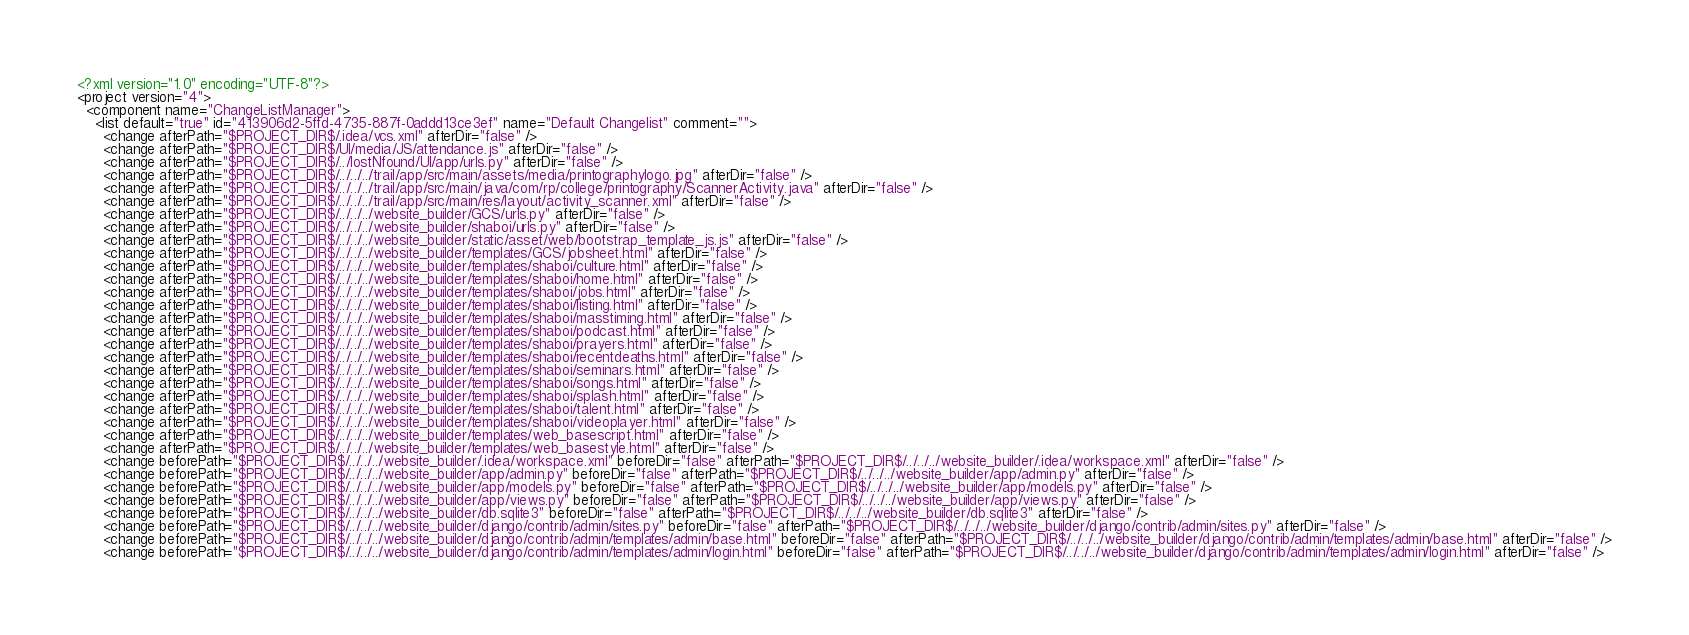<code> <loc_0><loc_0><loc_500><loc_500><_XML_><?xml version="1.0" encoding="UTF-8"?>
<project version="4">
  <component name="ChangeListManager">
    <list default="true" id="413906d2-5ffd-4735-887f-0addd13ce3ef" name="Default Changelist" comment="">
      <change afterPath="$PROJECT_DIR$/.idea/vcs.xml" afterDir="false" />
      <change afterPath="$PROJECT_DIR$/UI/media/JS/attendance.js" afterDir="false" />
      <change afterPath="$PROJECT_DIR$/../lostNfound/UI/app/urls.py" afterDir="false" />
      <change afterPath="$PROJECT_DIR$/../../../trail/app/src/main/assets/media/printographylogo.jpg" afterDir="false" />
      <change afterPath="$PROJECT_DIR$/../../../trail/app/src/main/java/com/rp/college/printography/ScannerActivity.java" afterDir="false" />
      <change afterPath="$PROJECT_DIR$/../../../trail/app/src/main/res/layout/activity_scanner.xml" afterDir="false" />
      <change afterPath="$PROJECT_DIR$/../../../website_builder/GCS/urls.py" afterDir="false" />
      <change afterPath="$PROJECT_DIR$/../../../website_builder/shaboi/urls.py" afterDir="false" />
      <change afterPath="$PROJECT_DIR$/../../../website_builder/static/asset/web/bootstrap_template_js.js" afterDir="false" />
      <change afterPath="$PROJECT_DIR$/../../../website_builder/templates/GCS/jobsheet.html" afterDir="false" />
      <change afterPath="$PROJECT_DIR$/../../../website_builder/templates/shaboi/culture.html" afterDir="false" />
      <change afterPath="$PROJECT_DIR$/../../../website_builder/templates/shaboi/home.html" afterDir="false" />
      <change afterPath="$PROJECT_DIR$/../../../website_builder/templates/shaboi/jobs.html" afterDir="false" />
      <change afterPath="$PROJECT_DIR$/../../../website_builder/templates/shaboi/listing.html" afterDir="false" />
      <change afterPath="$PROJECT_DIR$/../../../website_builder/templates/shaboi/masstiming.html" afterDir="false" />
      <change afterPath="$PROJECT_DIR$/../../../website_builder/templates/shaboi/podcast.html" afterDir="false" />
      <change afterPath="$PROJECT_DIR$/../../../website_builder/templates/shaboi/prayers.html" afterDir="false" />
      <change afterPath="$PROJECT_DIR$/../../../website_builder/templates/shaboi/recentdeaths.html" afterDir="false" />
      <change afterPath="$PROJECT_DIR$/../../../website_builder/templates/shaboi/seminars.html" afterDir="false" />
      <change afterPath="$PROJECT_DIR$/../../../website_builder/templates/shaboi/songs.html" afterDir="false" />
      <change afterPath="$PROJECT_DIR$/../../../website_builder/templates/shaboi/splash.html" afterDir="false" />
      <change afterPath="$PROJECT_DIR$/../../../website_builder/templates/shaboi/talent.html" afterDir="false" />
      <change afterPath="$PROJECT_DIR$/../../../website_builder/templates/shaboi/videoplayer.html" afterDir="false" />
      <change afterPath="$PROJECT_DIR$/../../../website_builder/templates/web_basescript.html" afterDir="false" />
      <change afterPath="$PROJECT_DIR$/../../../website_builder/templates/web_basestyle.html" afterDir="false" />
      <change beforePath="$PROJECT_DIR$/../../../website_builder/.idea/workspace.xml" beforeDir="false" afterPath="$PROJECT_DIR$/../../../website_builder/.idea/workspace.xml" afterDir="false" />
      <change beforePath="$PROJECT_DIR$/../../../website_builder/app/admin.py" beforeDir="false" afterPath="$PROJECT_DIR$/../../../website_builder/app/admin.py" afterDir="false" />
      <change beforePath="$PROJECT_DIR$/../../../website_builder/app/models.py" beforeDir="false" afterPath="$PROJECT_DIR$/../../../website_builder/app/models.py" afterDir="false" />
      <change beforePath="$PROJECT_DIR$/../../../website_builder/app/views.py" beforeDir="false" afterPath="$PROJECT_DIR$/../../../website_builder/app/views.py" afterDir="false" />
      <change beforePath="$PROJECT_DIR$/../../../website_builder/db.sqlite3" beforeDir="false" afterPath="$PROJECT_DIR$/../../../website_builder/db.sqlite3" afterDir="false" />
      <change beforePath="$PROJECT_DIR$/../../../website_builder/django/contrib/admin/sites.py" beforeDir="false" afterPath="$PROJECT_DIR$/../../../website_builder/django/contrib/admin/sites.py" afterDir="false" />
      <change beforePath="$PROJECT_DIR$/../../../website_builder/django/contrib/admin/templates/admin/base.html" beforeDir="false" afterPath="$PROJECT_DIR$/../../../website_builder/django/contrib/admin/templates/admin/base.html" afterDir="false" />
      <change beforePath="$PROJECT_DIR$/../../../website_builder/django/contrib/admin/templates/admin/login.html" beforeDir="false" afterPath="$PROJECT_DIR$/../../../website_builder/django/contrib/admin/templates/admin/login.html" afterDir="false" /></code> 